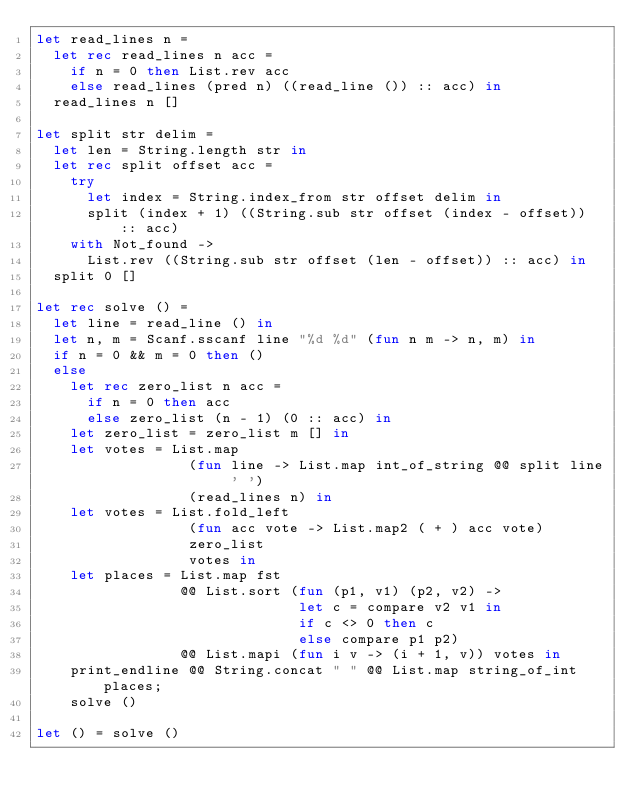<code> <loc_0><loc_0><loc_500><loc_500><_OCaml_>let read_lines n =
  let rec read_lines n acc =
    if n = 0 then List.rev acc
    else read_lines (pred n) ((read_line ()) :: acc) in
  read_lines n []

let split str delim =
  let len = String.length str in
  let rec split offset acc =
    try
      let index = String.index_from str offset delim in
      split (index + 1) ((String.sub str offset (index - offset)) :: acc)
    with Not_found ->
      List.rev ((String.sub str offset (len - offset)) :: acc) in
  split 0 []

let rec solve () =
  let line = read_line () in
  let n, m = Scanf.sscanf line "%d %d" (fun n m -> n, m) in
  if n = 0 && m = 0 then ()
  else
    let rec zero_list n acc =
      if n = 0 then acc
      else zero_list (n - 1) (0 :: acc) in
    let zero_list = zero_list m [] in
    let votes = List.map
                  (fun line -> List.map int_of_string @@ split line ' ')
                  (read_lines n) in
    let votes = List.fold_left
                  (fun acc vote -> List.map2 ( + ) acc vote)
                  zero_list
                  votes in
    let places = List.map fst
                 @@ List.sort (fun (p1, v1) (p2, v2) ->
                               let c = compare v2 v1 in
                               if c <> 0 then c
                               else compare p1 p2)
                 @@ List.mapi (fun i v -> (i + 1, v)) votes in
    print_endline @@ String.concat " " @@ List.map string_of_int places;
    solve ()

let () = solve ()</code> 